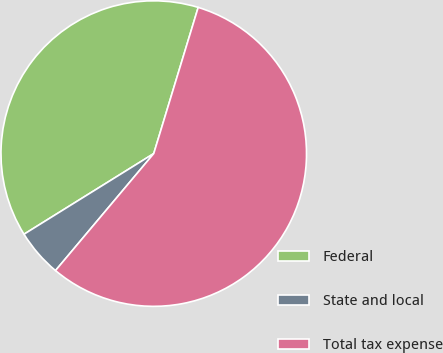<chart> <loc_0><loc_0><loc_500><loc_500><pie_chart><fcel>Federal<fcel>State and local<fcel>Total tax expense<nl><fcel>38.55%<fcel>5.03%<fcel>56.42%<nl></chart> 